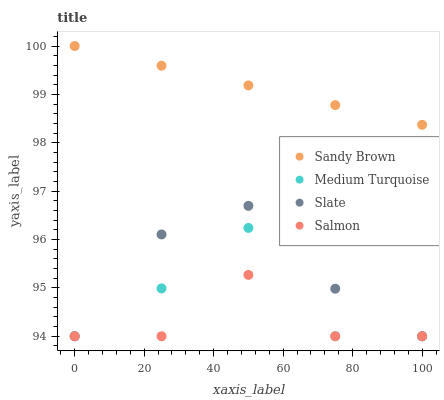Does Salmon have the minimum area under the curve?
Answer yes or no. Yes. Does Sandy Brown have the maximum area under the curve?
Answer yes or no. Yes. Does Slate have the minimum area under the curve?
Answer yes or no. No. Does Slate have the maximum area under the curve?
Answer yes or no. No. Is Sandy Brown the smoothest?
Answer yes or no. Yes. Is Medium Turquoise the roughest?
Answer yes or no. Yes. Is Slate the smoothest?
Answer yes or no. No. Is Slate the roughest?
Answer yes or no. No. Does Salmon have the lowest value?
Answer yes or no. Yes. Does Sandy Brown have the lowest value?
Answer yes or no. No. Does Sandy Brown have the highest value?
Answer yes or no. Yes. Does Slate have the highest value?
Answer yes or no. No. Is Salmon less than Sandy Brown?
Answer yes or no. Yes. Is Sandy Brown greater than Slate?
Answer yes or no. Yes. Does Slate intersect Salmon?
Answer yes or no. Yes. Is Slate less than Salmon?
Answer yes or no. No. Is Slate greater than Salmon?
Answer yes or no. No. Does Salmon intersect Sandy Brown?
Answer yes or no. No. 